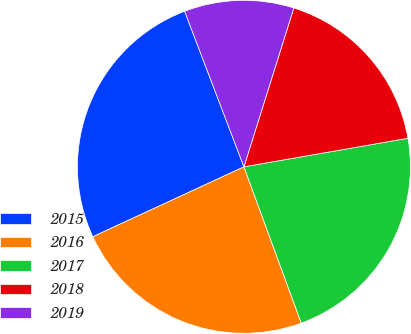Convert chart to OTSL. <chart><loc_0><loc_0><loc_500><loc_500><pie_chart><fcel>2015<fcel>2016<fcel>2017<fcel>2018<fcel>2019<nl><fcel>26.1%<fcel>23.7%<fcel>22.15%<fcel>17.41%<fcel>10.64%<nl></chart> 